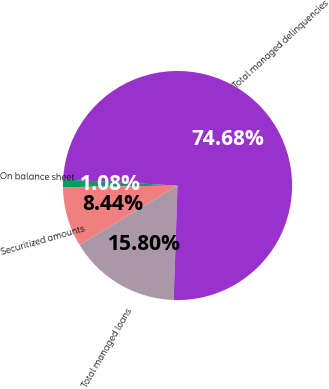Convert chart. <chart><loc_0><loc_0><loc_500><loc_500><pie_chart><fcel>On balance sheet<fcel>Securitized amounts<fcel>Total managed loans<fcel>Total managed delinquencies<nl><fcel>1.08%<fcel>8.44%<fcel>15.8%<fcel>74.68%<nl></chart> 